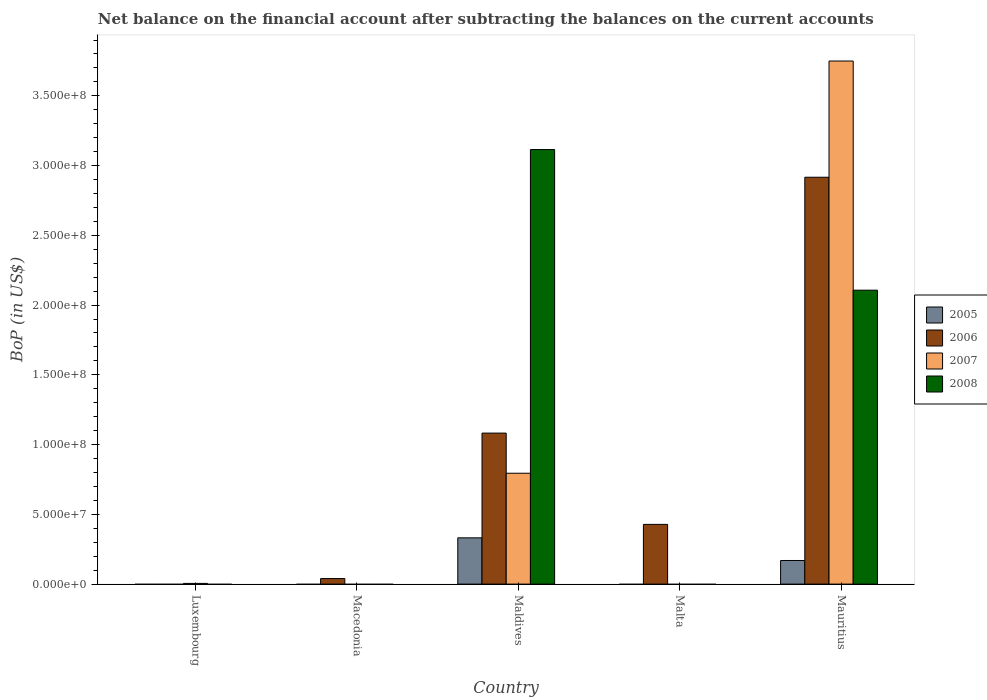How many bars are there on the 3rd tick from the left?
Your answer should be compact. 4. How many bars are there on the 1st tick from the right?
Your answer should be very brief. 4. What is the label of the 3rd group of bars from the left?
Keep it short and to the point. Maldives. What is the Balance of Payments in 2007 in Malta?
Keep it short and to the point. 0. Across all countries, what is the maximum Balance of Payments in 2005?
Keep it short and to the point. 3.32e+07. Across all countries, what is the minimum Balance of Payments in 2008?
Offer a very short reply. 0. In which country was the Balance of Payments in 2007 maximum?
Offer a terse response. Mauritius. What is the total Balance of Payments in 2008 in the graph?
Provide a short and direct response. 5.22e+08. What is the difference between the Balance of Payments in 2006 in Maldives and that in Malta?
Provide a succinct answer. 6.54e+07. What is the difference between the Balance of Payments in 2006 in Macedonia and the Balance of Payments in 2008 in Luxembourg?
Provide a succinct answer. 3.96e+06. What is the average Balance of Payments in 2008 per country?
Your answer should be very brief. 1.04e+08. What is the difference between the Balance of Payments of/in 2005 and Balance of Payments of/in 2006 in Mauritius?
Your answer should be compact. -2.75e+08. In how many countries, is the Balance of Payments in 2008 greater than 290000000 US$?
Ensure brevity in your answer.  1. What is the difference between the highest and the second highest Balance of Payments in 2007?
Keep it short and to the point. -7.90e+07. What is the difference between the highest and the lowest Balance of Payments in 2005?
Your answer should be very brief. 3.32e+07. Is the sum of the Balance of Payments in 2007 in Luxembourg and Maldives greater than the maximum Balance of Payments in 2008 across all countries?
Provide a short and direct response. No. Are the values on the major ticks of Y-axis written in scientific E-notation?
Ensure brevity in your answer.  Yes. Does the graph contain any zero values?
Keep it short and to the point. Yes. Does the graph contain grids?
Your response must be concise. No. Where does the legend appear in the graph?
Offer a very short reply. Center right. How many legend labels are there?
Offer a terse response. 4. What is the title of the graph?
Offer a very short reply. Net balance on the financial account after subtracting the balances on the current accounts. What is the label or title of the X-axis?
Your answer should be very brief. Country. What is the label or title of the Y-axis?
Make the answer very short. BoP (in US$). What is the BoP (in US$) in 2005 in Luxembourg?
Your response must be concise. 0. What is the BoP (in US$) in 2007 in Luxembourg?
Provide a short and direct response. 4.90e+05. What is the BoP (in US$) of 2008 in Luxembourg?
Ensure brevity in your answer.  0. What is the BoP (in US$) in 2005 in Macedonia?
Your response must be concise. 0. What is the BoP (in US$) of 2006 in Macedonia?
Provide a short and direct response. 3.96e+06. What is the BoP (in US$) of 2007 in Macedonia?
Your answer should be very brief. 0. What is the BoP (in US$) of 2005 in Maldives?
Offer a very short reply. 3.32e+07. What is the BoP (in US$) of 2006 in Maldives?
Your response must be concise. 1.08e+08. What is the BoP (in US$) of 2007 in Maldives?
Make the answer very short. 7.95e+07. What is the BoP (in US$) of 2008 in Maldives?
Make the answer very short. 3.11e+08. What is the BoP (in US$) of 2006 in Malta?
Provide a succinct answer. 4.28e+07. What is the BoP (in US$) in 2007 in Malta?
Make the answer very short. 0. What is the BoP (in US$) of 2005 in Mauritius?
Provide a short and direct response. 1.69e+07. What is the BoP (in US$) in 2006 in Mauritius?
Your response must be concise. 2.92e+08. What is the BoP (in US$) in 2007 in Mauritius?
Your answer should be compact. 3.75e+08. What is the BoP (in US$) in 2008 in Mauritius?
Your answer should be very brief. 2.11e+08. Across all countries, what is the maximum BoP (in US$) in 2005?
Keep it short and to the point. 3.32e+07. Across all countries, what is the maximum BoP (in US$) in 2006?
Offer a very short reply. 2.92e+08. Across all countries, what is the maximum BoP (in US$) of 2007?
Your answer should be compact. 3.75e+08. Across all countries, what is the maximum BoP (in US$) in 2008?
Keep it short and to the point. 3.11e+08. Across all countries, what is the minimum BoP (in US$) of 2007?
Your answer should be very brief. 0. What is the total BoP (in US$) in 2005 in the graph?
Provide a short and direct response. 5.01e+07. What is the total BoP (in US$) of 2006 in the graph?
Your response must be concise. 4.47e+08. What is the total BoP (in US$) in 2007 in the graph?
Your response must be concise. 4.55e+08. What is the total BoP (in US$) in 2008 in the graph?
Give a very brief answer. 5.22e+08. What is the difference between the BoP (in US$) of 2007 in Luxembourg and that in Maldives?
Offer a terse response. -7.90e+07. What is the difference between the BoP (in US$) of 2007 in Luxembourg and that in Mauritius?
Your answer should be compact. -3.74e+08. What is the difference between the BoP (in US$) of 2006 in Macedonia and that in Maldives?
Keep it short and to the point. -1.04e+08. What is the difference between the BoP (in US$) in 2006 in Macedonia and that in Malta?
Provide a short and direct response. -3.89e+07. What is the difference between the BoP (in US$) of 2006 in Macedonia and that in Mauritius?
Keep it short and to the point. -2.88e+08. What is the difference between the BoP (in US$) in 2006 in Maldives and that in Malta?
Provide a short and direct response. 6.54e+07. What is the difference between the BoP (in US$) of 2005 in Maldives and that in Mauritius?
Provide a succinct answer. 1.62e+07. What is the difference between the BoP (in US$) in 2006 in Maldives and that in Mauritius?
Give a very brief answer. -1.83e+08. What is the difference between the BoP (in US$) in 2007 in Maldives and that in Mauritius?
Your response must be concise. -2.95e+08. What is the difference between the BoP (in US$) of 2008 in Maldives and that in Mauritius?
Offer a very short reply. 1.01e+08. What is the difference between the BoP (in US$) of 2006 in Malta and that in Mauritius?
Provide a succinct answer. -2.49e+08. What is the difference between the BoP (in US$) in 2007 in Luxembourg and the BoP (in US$) in 2008 in Maldives?
Give a very brief answer. -3.11e+08. What is the difference between the BoP (in US$) in 2007 in Luxembourg and the BoP (in US$) in 2008 in Mauritius?
Offer a terse response. -2.10e+08. What is the difference between the BoP (in US$) in 2006 in Macedonia and the BoP (in US$) in 2007 in Maldives?
Give a very brief answer. -7.55e+07. What is the difference between the BoP (in US$) of 2006 in Macedonia and the BoP (in US$) of 2008 in Maldives?
Provide a succinct answer. -3.08e+08. What is the difference between the BoP (in US$) of 2006 in Macedonia and the BoP (in US$) of 2007 in Mauritius?
Offer a very short reply. -3.71e+08. What is the difference between the BoP (in US$) of 2006 in Macedonia and the BoP (in US$) of 2008 in Mauritius?
Your answer should be very brief. -2.07e+08. What is the difference between the BoP (in US$) of 2005 in Maldives and the BoP (in US$) of 2006 in Malta?
Offer a very short reply. -9.65e+06. What is the difference between the BoP (in US$) of 2005 in Maldives and the BoP (in US$) of 2006 in Mauritius?
Offer a terse response. -2.58e+08. What is the difference between the BoP (in US$) of 2005 in Maldives and the BoP (in US$) of 2007 in Mauritius?
Ensure brevity in your answer.  -3.42e+08. What is the difference between the BoP (in US$) in 2005 in Maldives and the BoP (in US$) in 2008 in Mauritius?
Provide a succinct answer. -1.78e+08. What is the difference between the BoP (in US$) of 2006 in Maldives and the BoP (in US$) of 2007 in Mauritius?
Keep it short and to the point. -2.67e+08. What is the difference between the BoP (in US$) in 2006 in Maldives and the BoP (in US$) in 2008 in Mauritius?
Your answer should be very brief. -1.02e+08. What is the difference between the BoP (in US$) in 2007 in Maldives and the BoP (in US$) in 2008 in Mauritius?
Provide a succinct answer. -1.31e+08. What is the difference between the BoP (in US$) in 2006 in Malta and the BoP (in US$) in 2007 in Mauritius?
Give a very brief answer. -3.32e+08. What is the difference between the BoP (in US$) in 2006 in Malta and the BoP (in US$) in 2008 in Mauritius?
Offer a terse response. -1.68e+08. What is the average BoP (in US$) of 2005 per country?
Make the answer very short. 1.00e+07. What is the average BoP (in US$) of 2006 per country?
Offer a terse response. 8.93e+07. What is the average BoP (in US$) of 2007 per country?
Ensure brevity in your answer.  9.10e+07. What is the average BoP (in US$) in 2008 per country?
Keep it short and to the point. 1.04e+08. What is the difference between the BoP (in US$) in 2005 and BoP (in US$) in 2006 in Maldives?
Your answer should be compact. -7.51e+07. What is the difference between the BoP (in US$) in 2005 and BoP (in US$) in 2007 in Maldives?
Your answer should be very brief. -4.63e+07. What is the difference between the BoP (in US$) in 2005 and BoP (in US$) in 2008 in Maldives?
Your answer should be very brief. -2.78e+08. What is the difference between the BoP (in US$) of 2006 and BoP (in US$) of 2007 in Maldives?
Your answer should be compact. 2.88e+07. What is the difference between the BoP (in US$) of 2006 and BoP (in US$) of 2008 in Maldives?
Ensure brevity in your answer.  -2.03e+08. What is the difference between the BoP (in US$) of 2007 and BoP (in US$) of 2008 in Maldives?
Give a very brief answer. -2.32e+08. What is the difference between the BoP (in US$) in 2005 and BoP (in US$) in 2006 in Mauritius?
Provide a short and direct response. -2.75e+08. What is the difference between the BoP (in US$) of 2005 and BoP (in US$) of 2007 in Mauritius?
Your answer should be compact. -3.58e+08. What is the difference between the BoP (in US$) of 2005 and BoP (in US$) of 2008 in Mauritius?
Ensure brevity in your answer.  -1.94e+08. What is the difference between the BoP (in US$) in 2006 and BoP (in US$) in 2007 in Mauritius?
Give a very brief answer. -8.33e+07. What is the difference between the BoP (in US$) in 2006 and BoP (in US$) in 2008 in Mauritius?
Ensure brevity in your answer.  8.10e+07. What is the difference between the BoP (in US$) of 2007 and BoP (in US$) of 2008 in Mauritius?
Ensure brevity in your answer.  1.64e+08. What is the ratio of the BoP (in US$) of 2007 in Luxembourg to that in Maldives?
Keep it short and to the point. 0.01. What is the ratio of the BoP (in US$) in 2007 in Luxembourg to that in Mauritius?
Make the answer very short. 0. What is the ratio of the BoP (in US$) of 2006 in Macedonia to that in Maldives?
Your response must be concise. 0.04. What is the ratio of the BoP (in US$) in 2006 in Macedonia to that in Malta?
Give a very brief answer. 0.09. What is the ratio of the BoP (in US$) in 2006 in Macedonia to that in Mauritius?
Provide a short and direct response. 0.01. What is the ratio of the BoP (in US$) of 2006 in Maldives to that in Malta?
Your answer should be very brief. 2.53. What is the ratio of the BoP (in US$) of 2005 in Maldives to that in Mauritius?
Ensure brevity in your answer.  1.96. What is the ratio of the BoP (in US$) in 2006 in Maldives to that in Mauritius?
Offer a very short reply. 0.37. What is the ratio of the BoP (in US$) of 2007 in Maldives to that in Mauritius?
Provide a succinct answer. 0.21. What is the ratio of the BoP (in US$) of 2008 in Maldives to that in Mauritius?
Keep it short and to the point. 1.48. What is the ratio of the BoP (in US$) of 2006 in Malta to that in Mauritius?
Make the answer very short. 0.15. What is the difference between the highest and the second highest BoP (in US$) of 2006?
Make the answer very short. 1.83e+08. What is the difference between the highest and the second highest BoP (in US$) in 2007?
Your response must be concise. 2.95e+08. What is the difference between the highest and the lowest BoP (in US$) of 2005?
Keep it short and to the point. 3.32e+07. What is the difference between the highest and the lowest BoP (in US$) in 2006?
Keep it short and to the point. 2.92e+08. What is the difference between the highest and the lowest BoP (in US$) of 2007?
Your answer should be compact. 3.75e+08. What is the difference between the highest and the lowest BoP (in US$) in 2008?
Offer a very short reply. 3.11e+08. 